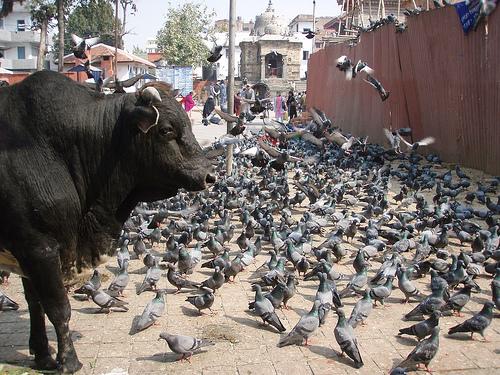How many bulls are there?
Give a very brief answer. 1. Is the cow a male or female?
Keep it brief. Male. How many birds are seen?
Keep it brief. Lots. What is the bull looking at?
Concise answer only. Birds. 